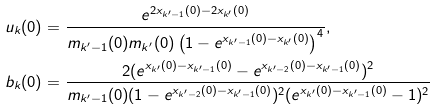Convert formula to latex. <formula><loc_0><loc_0><loc_500><loc_500>& u _ { k } ( 0 ) = \frac { e ^ { 2 x _ { k ^ { \prime } - 1 } ( 0 ) - 2 x _ { k ^ { \prime } } ( 0 ) } } { m _ { k ^ { \prime } - 1 } ( 0 ) m _ { k ^ { \prime } } ( 0 ) \left ( 1 - e ^ { x _ { k ^ { \prime } - 1 } ( 0 ) - x _ { k ^ { \prime } } ( 0 ) } \right ) ^ { 4 } } , \\ & b _ { k } ( 0 ) = \frac { 2 ( e ^ { x _ { k ^ { \prime } } ( 0 ) - x _ { k ^ { \prime } - 1 } ( 0 ) } - e ^ { x _ { k ^ { \prime } - 2 } ( 0 ) - x _ { k ^ { \prime } - 1 } ( 0 ) } ) ^ { 2 } } { m _ { k ^ { \prime } - 1 } ( 0 ) ( 1 - e ^ { x _ { k ^ { \prime } - 2 } ( 0 ) - x _ { k ^ { \prime } - 1 } ( 0 ) } ) ^ { 2 } ( e ^ { x _ { k ^ { \prime } } ( 0 ) - x _ { k ^ { \prime } - 1 } ( 0 ) } - 1 ) ^ { 2 } }</formula> 